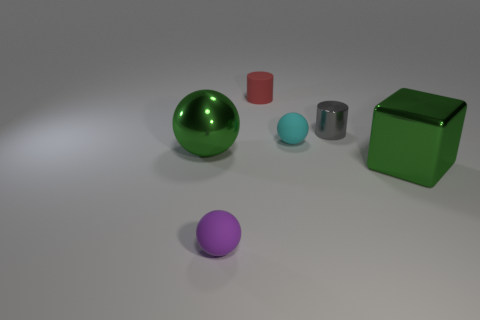Subtract all cyan balls. How many balls are left? 2 Add 4 shiny cylinders. How many objects exist? 10 Subtract all blocks. How many objects are left? 5 Subtract all red spheres. Subtract all red cubes. How many spheres are left? 3 Subtract all matte objects. Subtract all brown cylinders. How many objects are left? 3 Add 4 big green metal cubes. How many big green metal cubes are left? 5 Add 3 large spheres. How many large spheres exist? 4 Subtract 0 yellow balls. How many objects are left? 6 